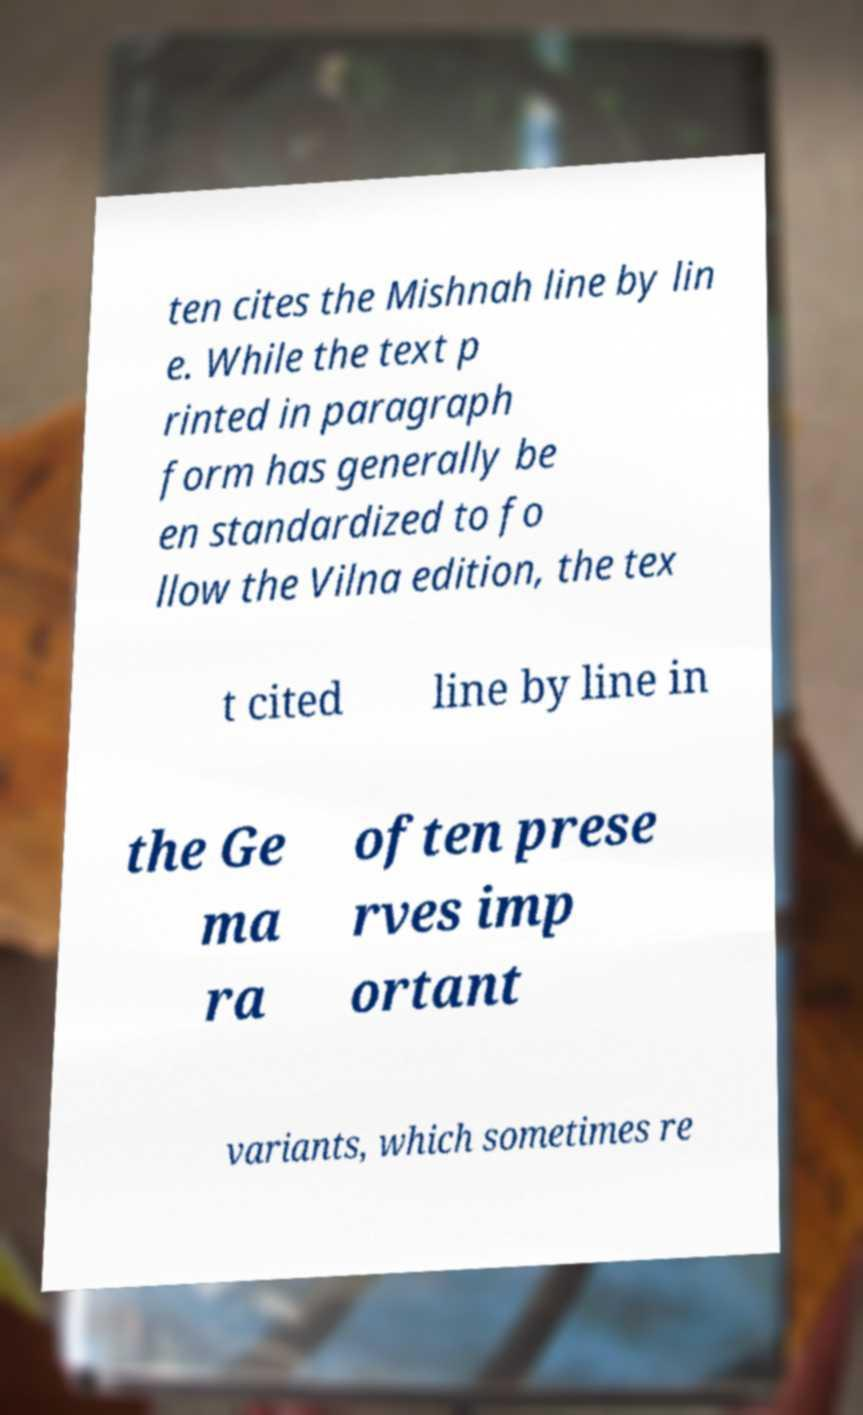Could you extract and type out the text from this image? ten cites the Mishnah line by lin e. While the text p rinted in paragraph form has generally be en standardized to fo llow the Vilna edition, the tex t cited line by line in the Ge ma ra often prese rves imp ortant variants, which sometimes re 